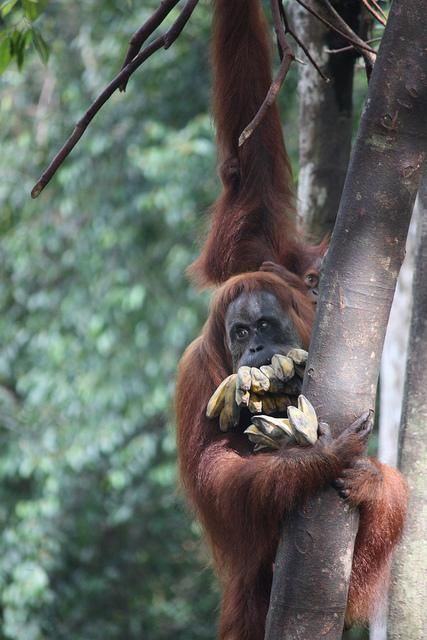What kind of fruit does the orangutan have in its mouth? Please explain your reasoning. bananas. He is holding a bunch of yellow curved fruits. 